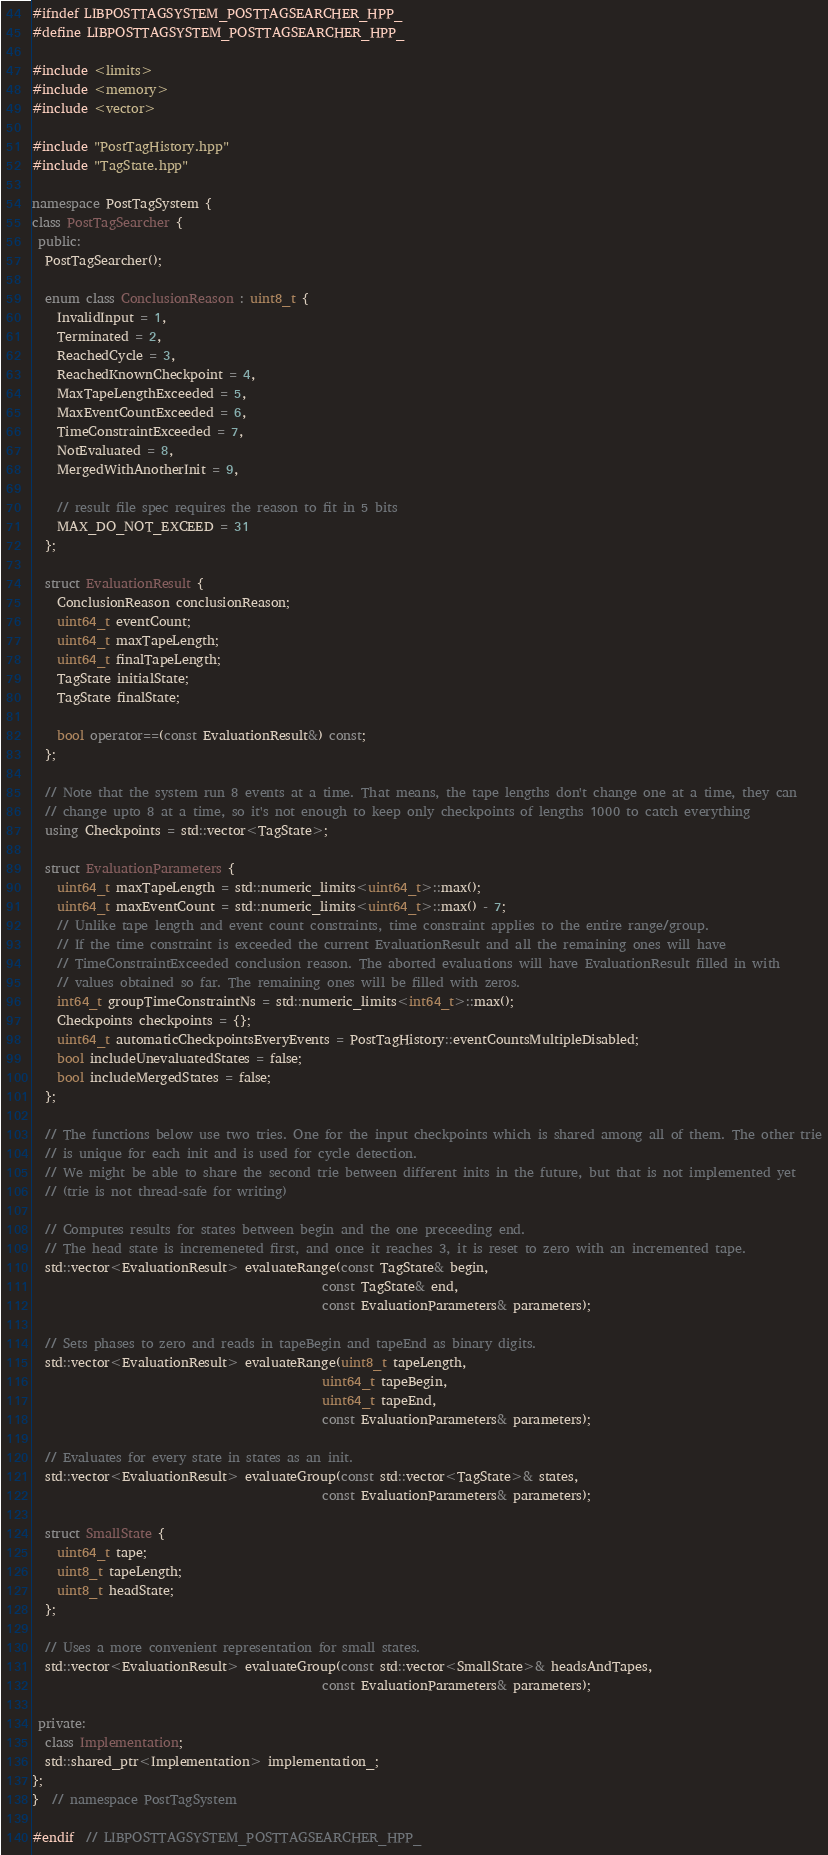<code> <loc_0><loc_0><loc_500><loc_500><_C++_>#ifndef LIBPOSTTAGSYSTEM_POSTTAGSEARCHER_HPP_
#define LIBPOSTTAGSYSTEM_POSTTAGSEARCHER_HPP_

#include <limits>
#include <memory>
#include <vector>

#include "PostTagHistory.hpp"
#include "TagState.hpp"

namespace PostTagSystem {
class PostTagSearcher {
 public:
  PostTagSearcher();

  enum class ConclusionReason : uint8_t {
    InvalidInput = 1,
    Terminated = 2,
    ReachedCycle = 3,
    ReachedKnownCheckpoint = 4,
    MaxTapeLengthExceeded = 5,
    MaxEventCountExceeded = 6,
    TimeConstraintExceeded = 7,
    NotEvaluated = 8,
    MergedWithAnotherInit = 9,

    // result file spec requires the reason to fit in 5 bits
    MAX_DO_NOT_EXCEED = 31
  };

  struct EvaluationResult {
    ConclusionReason conclusionReason;
    uint64_t eventCount;
    uint64_t maxTapeLength;
    uint64_t finalTapeLength;
    TagState initialState;
    TagState finalState;

    bool operator==(const EvaluationResult&) const;
  };

  // Note that the system run 8 events at a time. That means, the tape lengths don't change one at a time, they can
  // change upto 8 at a time, so it's not enough to keep only checkpoints of lengths 1000 to catch everything
  using Checkpoints = std::vector<TagState>;

  struct EvaluationParameters {
    uint64_t maxTapeLength = std::numeric_limits<uint64_t>::max();
    uint64_t maxEventCount = std::numeric_limits<uint64_t>::max() - 7;
    // Unlike tape length and event count constraints, time constraint applies to the entire range/group.
    // If the time constraint is exceeded the current EvaluationResult and all the remaining ones will have
    // TimeConstraintExceeded conclusion reason. The aborted evaluations will have EvaluationResult filled in with
    // values obtained so far. The remaining ones will be filled with zeros.
    int64_t groupTimeConstraintNs = std::numeric_limits<int64_t>::max();
    Checkpoints checkpoints = {};
    uint64_t automaticCheckpointsEveryEvents = PostTagHistory::eventCountsMultipleDisabled;
    bool includeUnevaluatedStates = false;
    bool includeMergedStates = false;
  };

  // The functions below use two tries. One for the input checkpoints which is shared among all of them. The other trie
  // is unique for each init and is used for cycle detection.
  // We might be able to share the second trie between different inits in the future, but that is not implemented yet
  // (trie is not thread-safe for writing)

  // Computes results for states between begin and the one preceeding end.
  // The head state is incremeneted first, and once it reaches 3, it is reset to zero with an incremented tape.
  std::vector<EvaluationResult> evaluateRange(const TagState& begin,
                                              const TagState& end,
                                              const EvaluationParameters& parameters);

  // Sets phases to zero and reads in tapeBegin and tapeEnd as binary digits.
  std::vector<EvaluationResult> evaluateRange(uint8_t tapeLength,
                                              uint64_t tapeBegin,
                                              uint64_t tapeEnd,
                                              const EvaluationParameters& parameters);

  // Evaluates for every state in states as an init.
  std::vector<EvaluationResult> evaluateGroup(const std::vector<TagState>& states,
                                              const EvaluationParameters& parameters);

  struct SmallState {
    uint64_t tape;
    uint8_t tapeLength;
    uint8_t headState;
  };

  // Uses a more convenient representation for small states.
  std::vector<EvaluationResult> evaluateGroup(const std::vector<SmallState>& headsAndTapes,
                                              const EvaluationParameters& parameters);

 private:
  class Implementation;
  std::shared_ptr<Implementation> implementation_;
};
}  // namespace PostTagSystem

#endif  // LIBPOSTTAGSYSTEM_POSTTAGSEARCHER_HPP_
</code> 